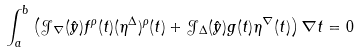Convert formula to latex. <formula><loc_0><loc_0><loc_500><loc_500>\int _ { a } ^ { b } \left ( \mathcal { J } _ { \nabla } ( \hat { y } ) f ^ { \rho } ( t ) ( \eta ^ { \Delta } ) ^ { \rho } ( t ) + \mathcal { J } _ { \Delta } ( \hat { y } ) g ( t ) \eta ^ { \nabla } ( t ) \right ) \nabla t = 0</formula> 